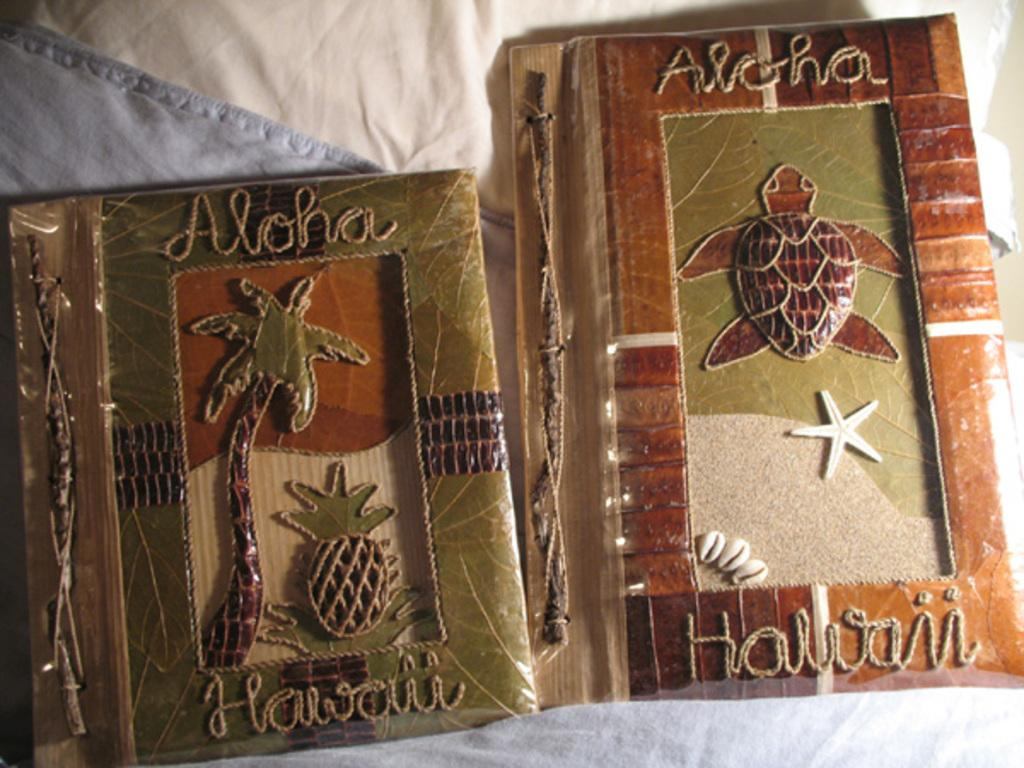<image>
Present a compact description of the photo's key features. The frame with the turtle has the words "Aloha" and "Hawaii" on it. 